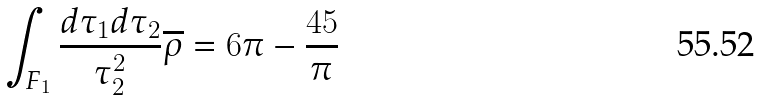Convert formula to latex. <formula><loc_0><loc_0><loc_500><loc_500>\int _ { F _ { 1 } } \frac { d \tau _ { 1 } d \tau _ { 2 } } { \tau _ { 2 } ^ { 2 } } \overline { \rho } = 6 \pi - \frac { 4 5 } { \pi }</formula> 